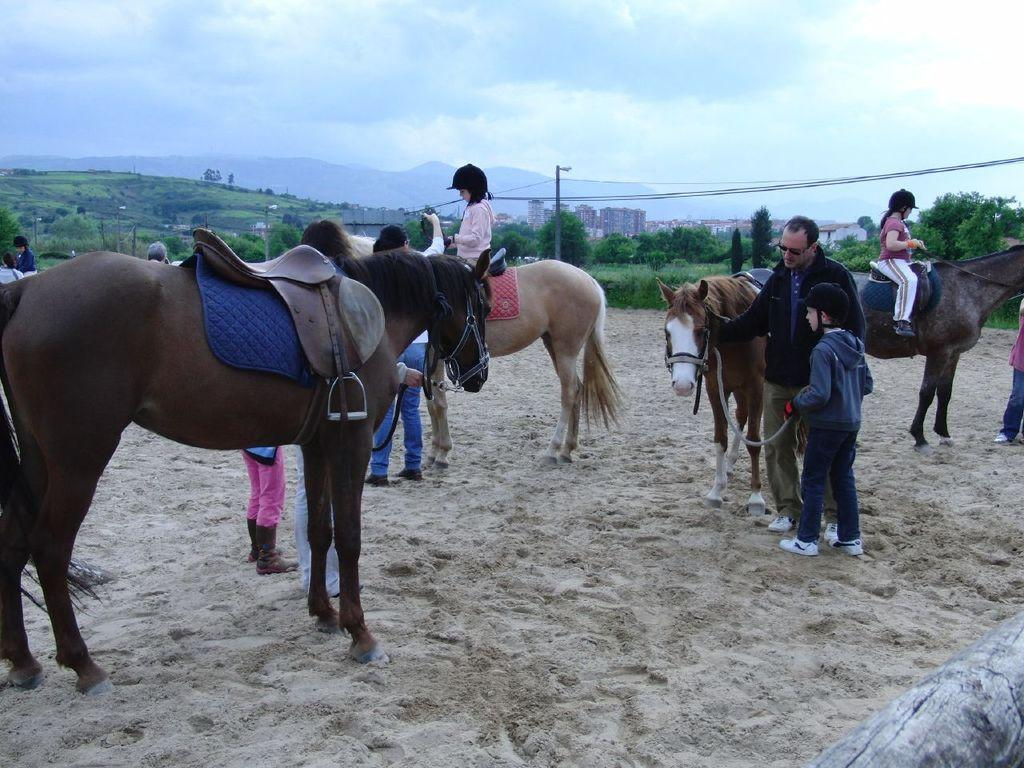What animals are present in the image? There are horses in the image. What is the terrain like where the horses are located? The horses are on a sandy land. Are there any people interacting with the horses? Yes, there are people sitting on some of the horses and people standing near the horses. What can be seen in the background of the image? There are trees, poles, mountains, and the sky visible in the background of the image. What color are the crayons used to draw the mountains in the image? There are no crayons present in the image, and the mountains are not drawn; they are a natural part of the landscape. 